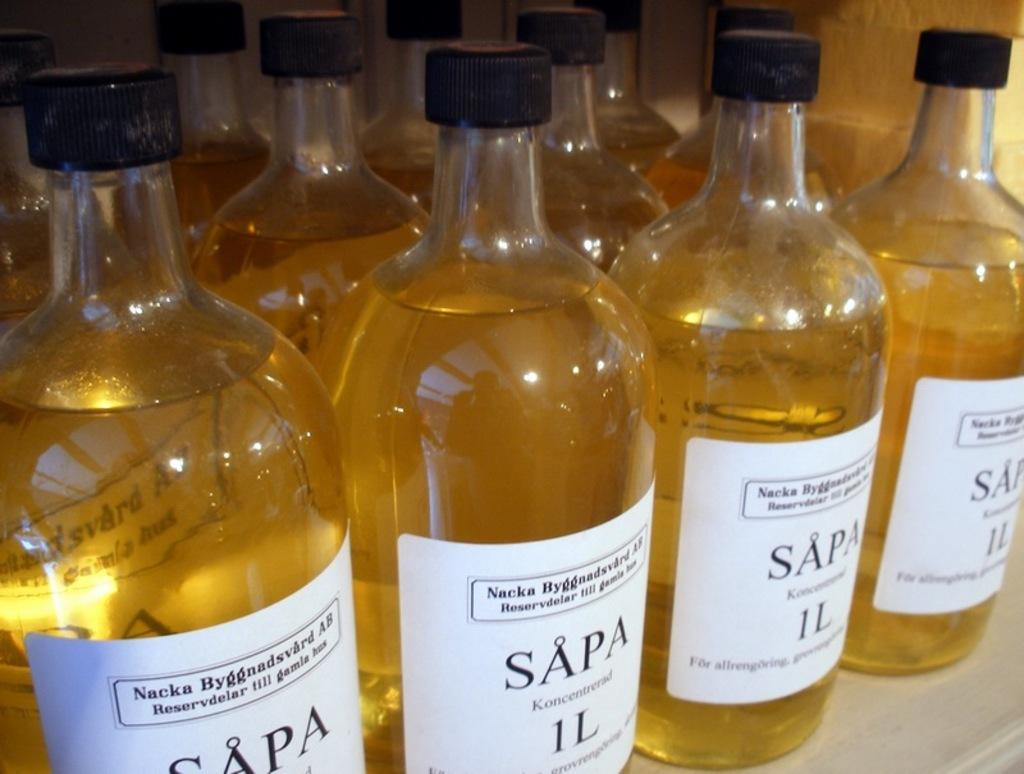<image>
Create a compact narrative representing the image presented. the word sapa is on the back of a bottle 